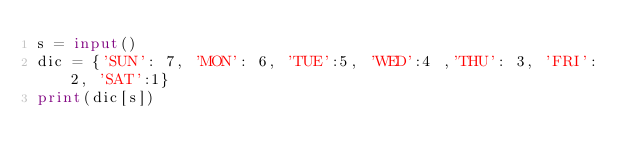Convert code to text. <code><loc_0><loc_0><loc_500><loc_500><_Python_>s = input()
dic = {'SUN': 7, 'MON': 6, 'TUE':5, 'WED':4 ,'THU': 3, 'FRI': 2, 'SAT':1}
print(dic[s])</code> 